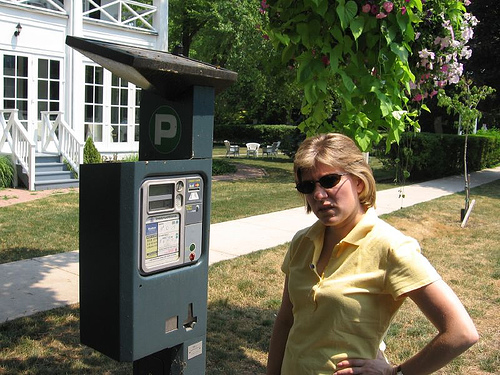Please extract the text content from this image. P 